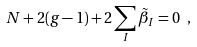<formula> <loc_0><loc_0><loc_500><loc_500>N + 2 ( g - 1 ) + 2 \sum _ { I } \tilde { \beta } _ { I } = 0 \ ,</formula> 